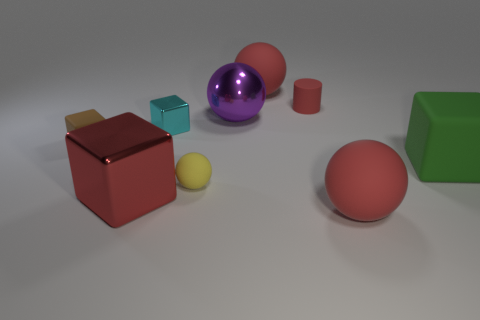Subtract all tiny balls. How many balls are left? 3 Subtract all red blocks. How many blocks are left? 3 Add 1 brown cubes. How many objects exist? 10 Subtract 3 cubes. How many cubes are left? 1 Subtract all cylinders. How many objects are left? 8 Subtract all green spheres. Subtract all blue blocks. How many spheres are left? 4 Subtract all yellow balls. How many cyan cubes are left? 1 Subtract all small cyan metallic objects. Subtract all yellow rubber things. How many objects are left? 7 Add 6 tiny yellow matte spheres. How many tiny yellow matte spheres are left? 7 Add 3 tiny rubber objects. How many tiny rubber objects exist? 6 